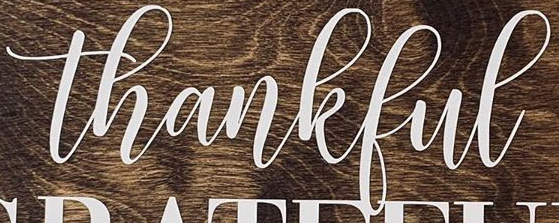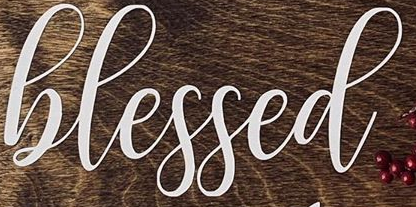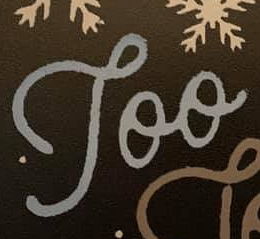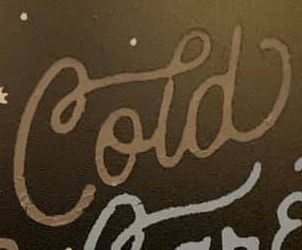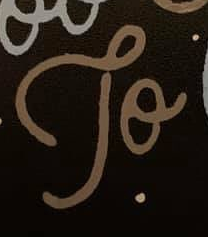What text appears in these images from left to right, separated by a semicolon? thankful; hlessed; Too; Cold; To 